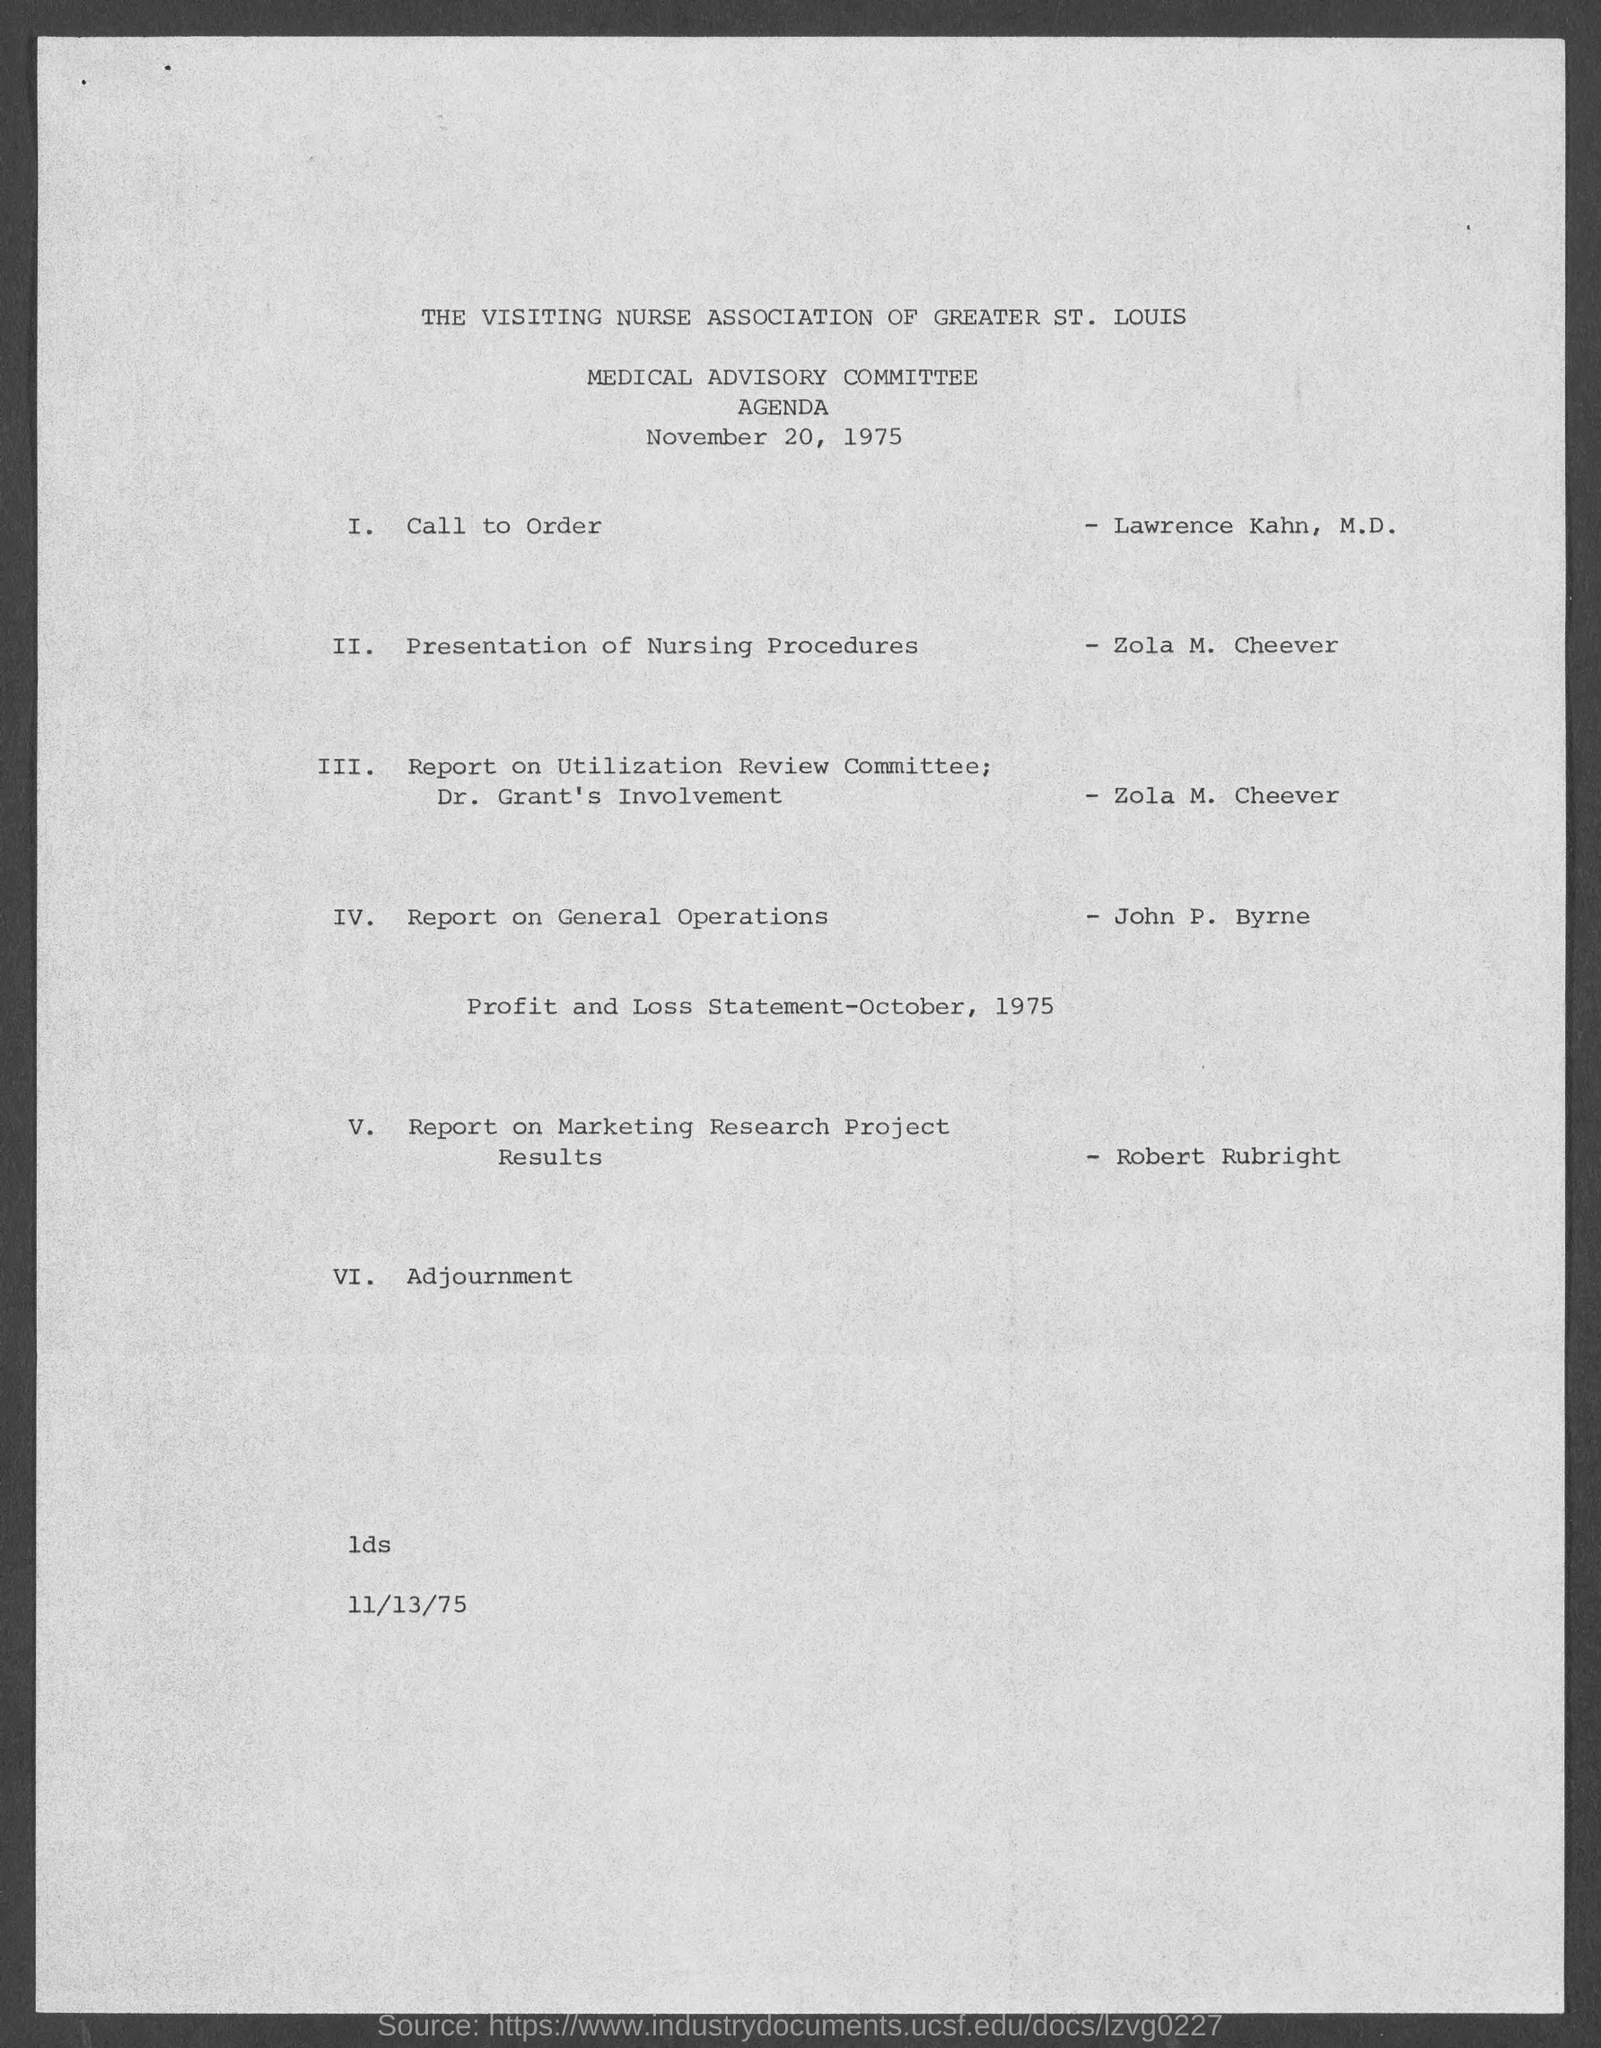What is the date of Agenda?
Keep it short and to the point. November 20, 1975. 